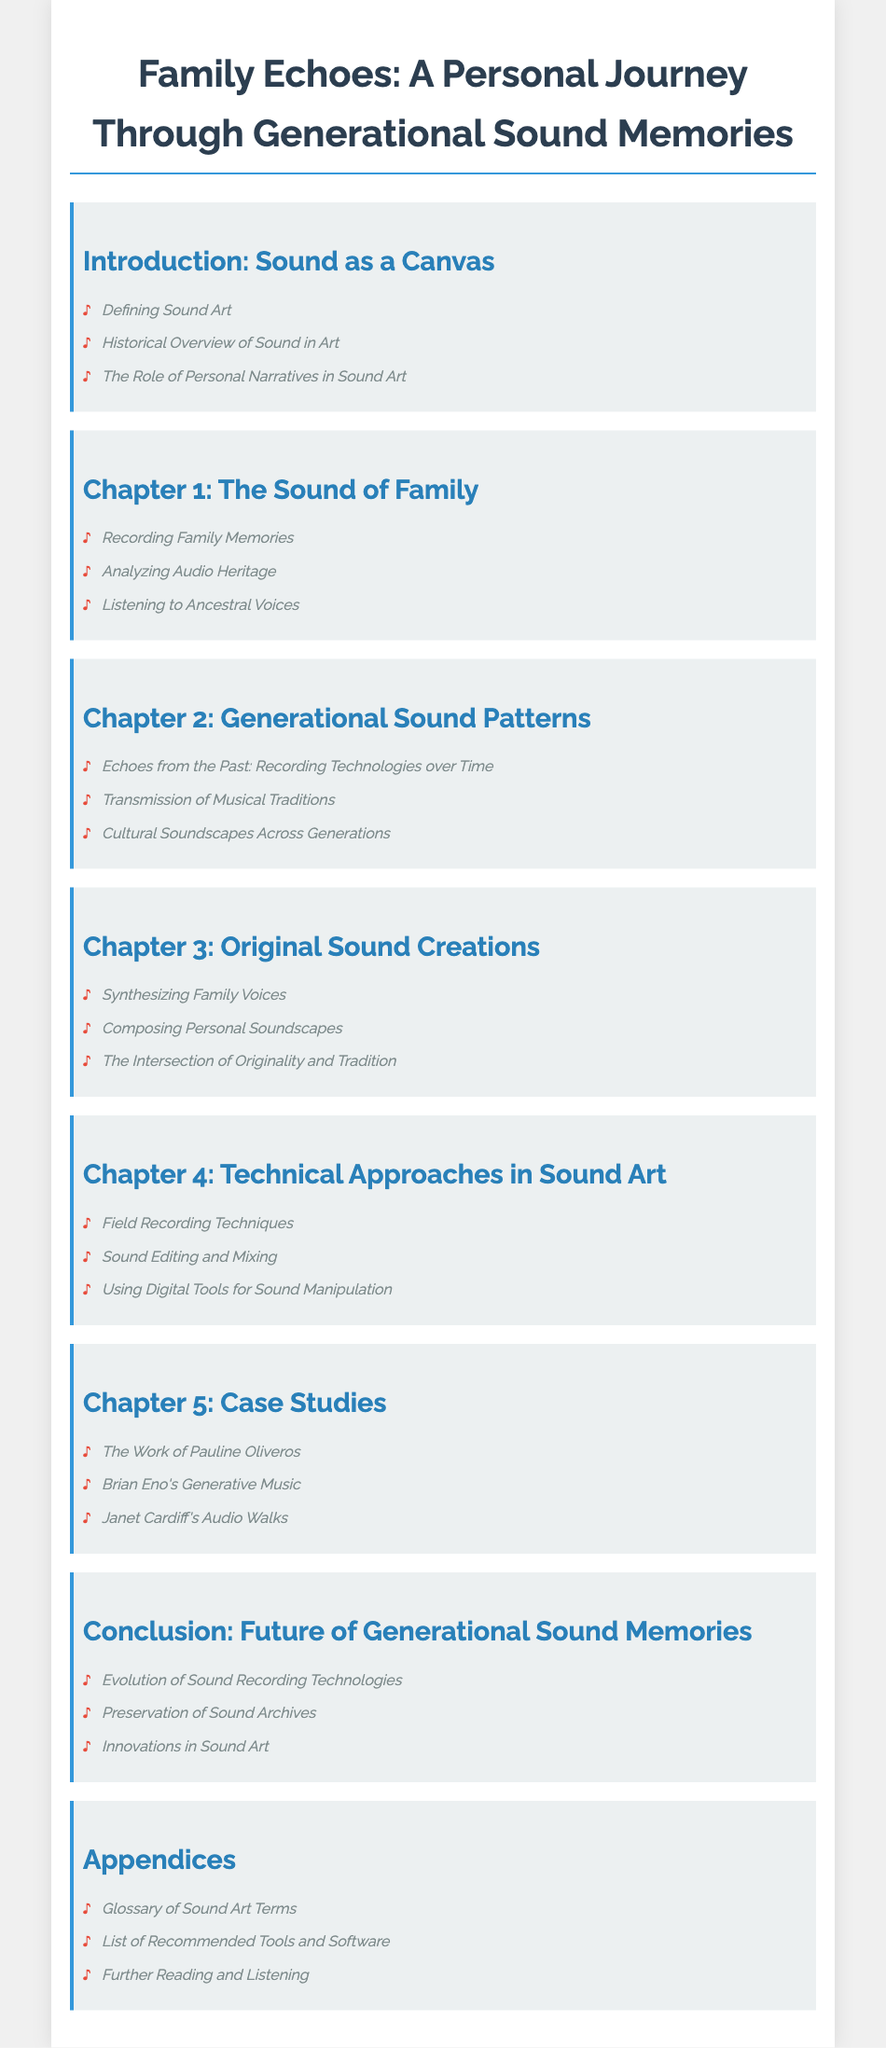what is the title of the document? The title, prominently displayed at the top, presents the main theme of the work.
Answer: Family Echoes: A Personal Journey Through Generational Sound Memories how many chapters are there in the document? The chapters are listed in the Table of Contents, indicating the total number of distinct sections.
Answer: Five which chapter discusses family memories? Chapter 1 focuses explicitly on family-related sound experiences and memories.
Answer: Chapter 1: The Sound of Family what is the main topic of the conclusion? The conclusion summarizes the key themes addressed throughout the document and highlights future insights.
Answer: Future of Generational Sound Memories who is mentioned as an influential figure in the case studies? The case studies present notable artists whose work aligns with the themes of sound art discussed in the document.
Answer: Pauline Oliveros what does the section on field recordings cover? This section highlights specific techniques essential for capturing audio in various environments.
Answer: Field Recording Techniques what type of art is emphasized in the introduction? The introduction defines and establishes the context for an innovative form of art that involves audio elements.
Answer: Sound Art what are the appendices focused on? The appendices complement the main content by providing additional resources and information relevant to sound art.
Answer: Glossary of Sound Art Terms 